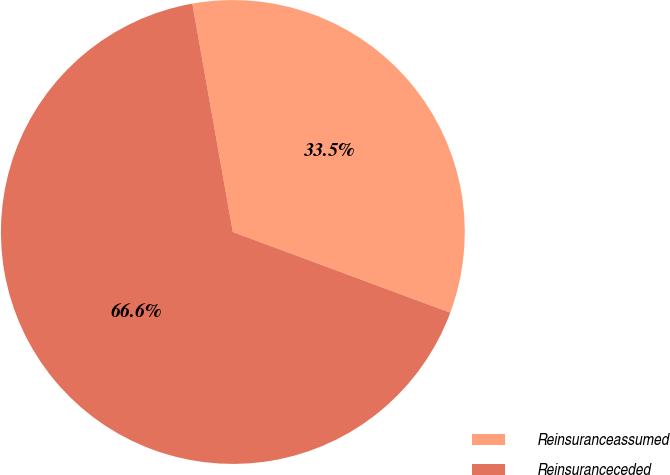Convert chart to OTSL. <chart><loc_0><loc_0><loc_500><loc_500><pie_chart><fcel>Reinsuranceassumed<fcel>Reinsuranceceded<nl><fcel>33.45%<fcel>66.55%<nl></chart> 